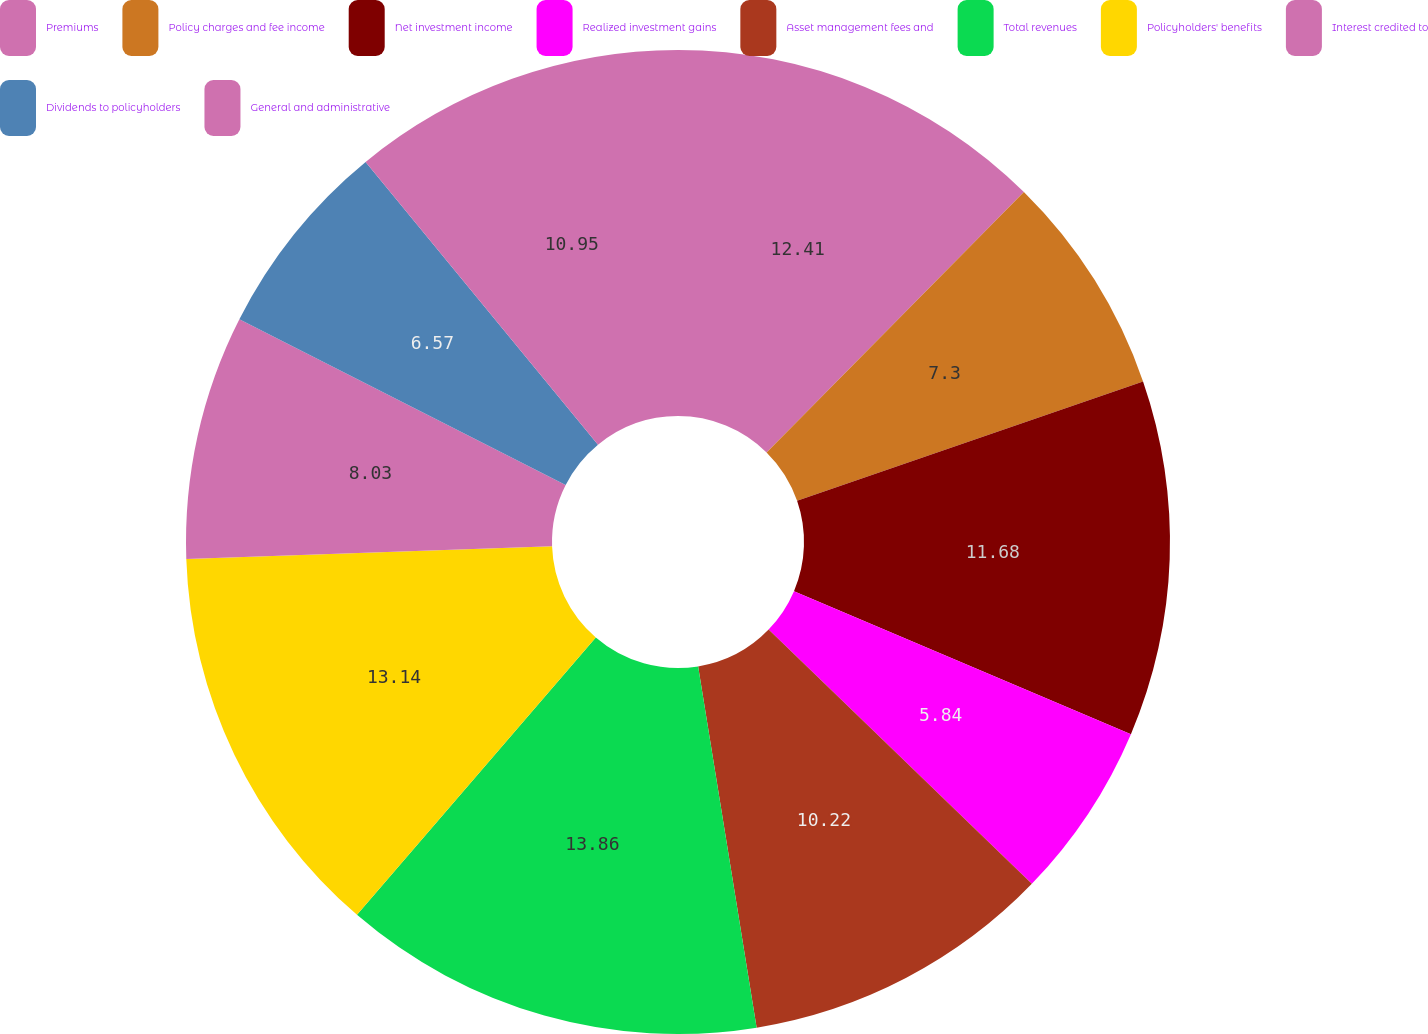Convert chart. <chart><loc_0><loc_0><loc_500><loc_500><pie_chart><fcel>Premiums<fcel>Policy charges and fee income<fcel>Net investment income<fcel>Realized investment gains<fcel>Asset management fees and<fcel>Total revenues<fcel>Policyholders' benefits<fcel>Interest credited to<fcel>Dividends to policyholders<fcel>General and administrative<nl><fcel>12.41%<fcel>7.3%<fcel>11.68%<fcel>5.84%<fcel>10.22%<fcel>13.87%<fcel>13.14%<fcel>8.03%<fcel>6.57%<fcel>10.95%<nl></chart> 